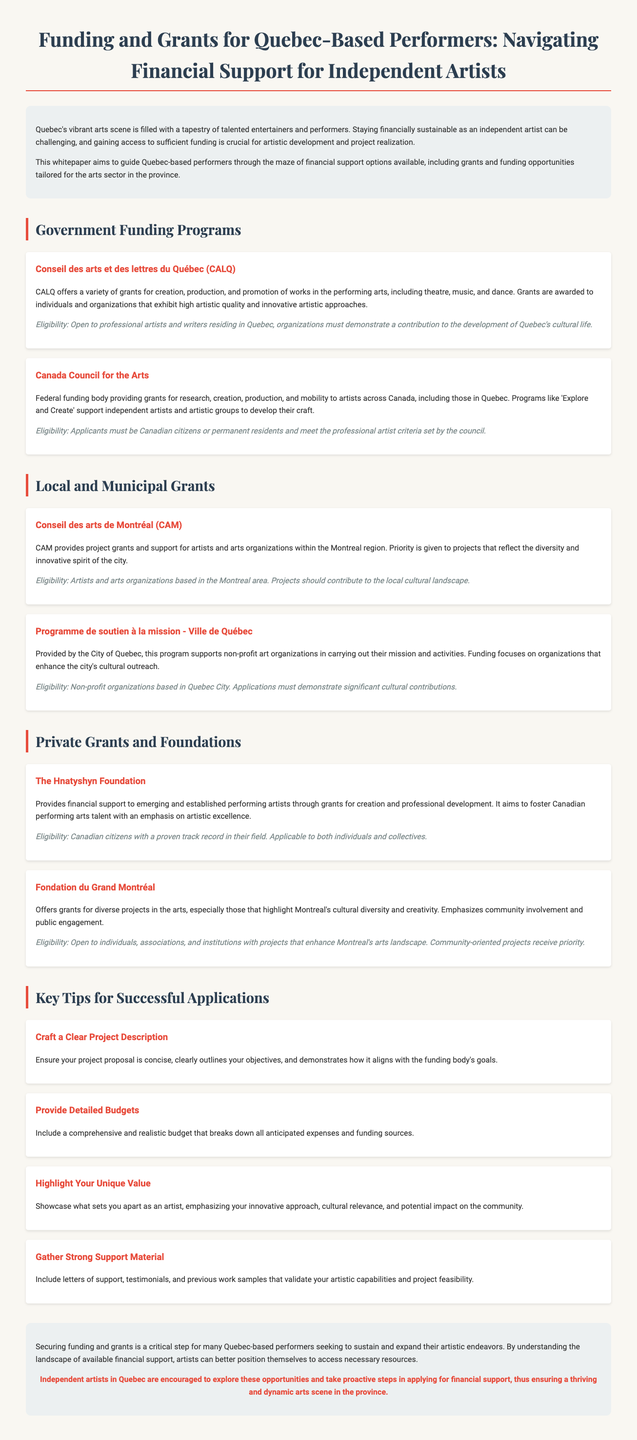What is the main purpose of the whitepaper? The whitepaper aims to guide Quebec-based performers through the maze of financial support options available.
Answer: Guide for financial support options What does CALQ stand for? CALQ stands for Conseil des arts et des lettres du Québec.
Answer: Conseil des arts et des lettres du Québec What type of grants does the Canada Council for the Arts provide? The Canada Council for the Arts provides grants for research, creation, production, and mobility.
Answer: Research, creation, production, and mobility Which local grant program prioritizes projects reflecting the diversity of Montreal? The program that prioritizes such projects is Conseil des arts de Montréal (CAM).
Answer: Conseil des arts de Montréal What is a key tip for successful grant applications? A key tip is to craft a clear project description.
Answer: Craft a clear project description Who is eligible for funding from the Hnatyshyn Foundation? Eligibility includes Canadian citizens with a proven track record in their field.
Answer: Canadian citizens with a proven track record What type of organization is the Programme de soutien à la mission intended for? It is intended for non-profit art organizations.
Answer: Non-profit art organizations What is emphasized in the application process that may heighten the chances of success? Highlighting your unique value is emphasized.
Answer: Highlight your unique value 